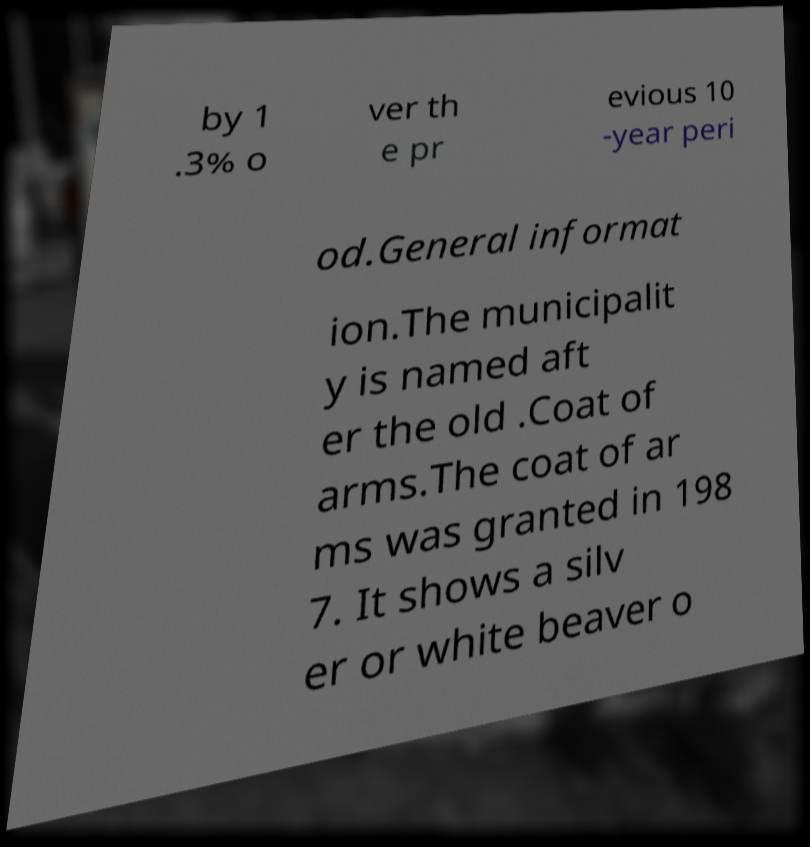Can you accurately transcribe the text from the provided image for me? by 1 .3% o ver th e pr evious 10 -year peri od.General informat ion.The municipalit y is named aft er the old .Coat of arms.The coat of ar ms was granted in 198 7. It shows a silv er or white beaver o 